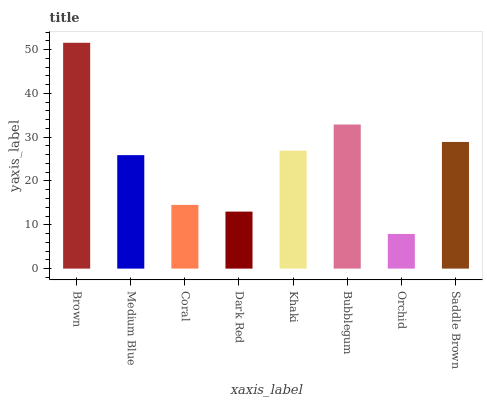Is Orchid the minimum?
Answer yes or no. Yes. Is Brown the maximum?
Answer yes or no. Yes. Is Medium Blue the minimum?
Answer yes or no. No. Is Medium Blue the maximum?
Answer yes or no. No. Is Brown greater than Medium Blue?
Answer yes or no. Yes. Is Medium Blue less than Brown?
Answer yes or no. Yes. Is Medium Blue greater than Brown?
Answer yes or no. No. Is Brown less than Medium Blue?
Answer yes or no. No. Is Khaki the high median?
Answer yes or no. Yes. Is Medium Blue the low median?
Answer yes or no. Yes. Is Saddle Brown the high median?
Answer yes or no. No. Is Orchid the low median?
Answer yes or no. No. 